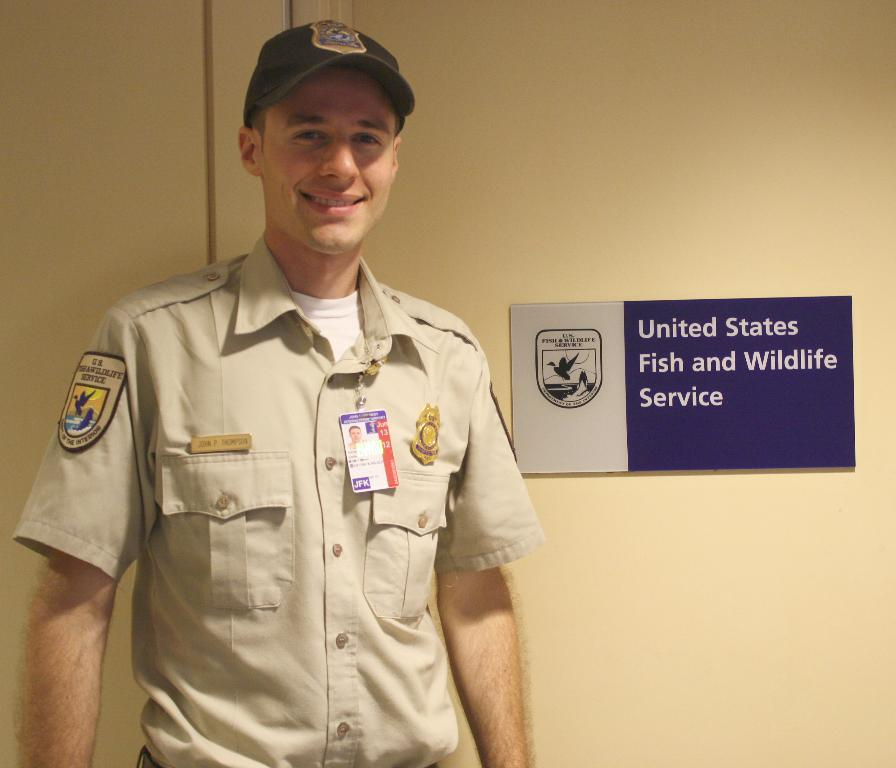What is the man in the image doing? The man is standing in the image. What expression does the man have on his face? The man is smiling. What can be seen on the wall in the background of the image? There is a board on the wall in the background of the image. What type of flag is the man holding in the image? There is no flag present in the image; the man is simply standing and smiling. 